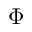Convert formula to latex. <formula><loc_0><loc_0><loc_500><loc_500>\Phi</formula> 